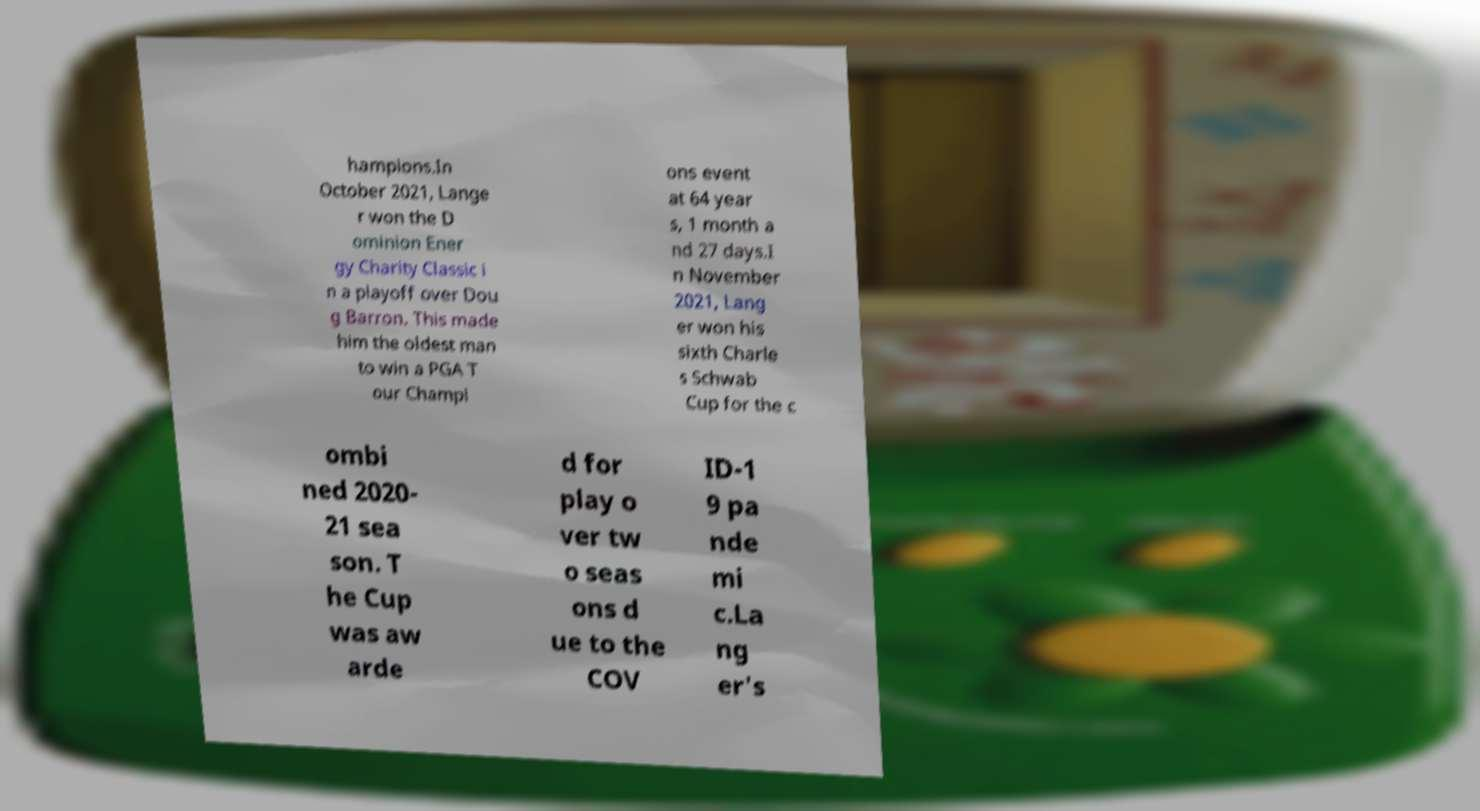Please read and relay the text visible in this image. What does it say? hampions.In October 2021, Lange r won the D ominion Ener gy Charity Classic i n a playoff over Dou g Barron. This made him the oldest man to win a PGA T our Champi ons event at 64 year s, 1 month a nd 27 days.I n November 2021, Lang er won his sixth Charle s Schwab Cup for the c ombi ned 2020- 21 sea son. T he Cup was aw arde d for play o ver tw o seas ons d ue to the COV ID-1 9 pa nde mi c.La ng er's 